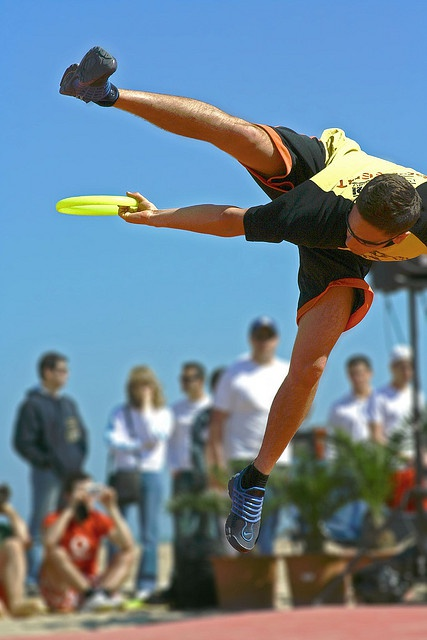Describe the objects in this image and their specific colors. I can see people in lightblue, black, maroon, and brown tones, people in lightblue, gray, and maroon tones, people in lightblue, blue, gray, and black tones, people in lightblue, gray, and white tones, and people in lightblue, darkgray, white, and gray tones in this image. 